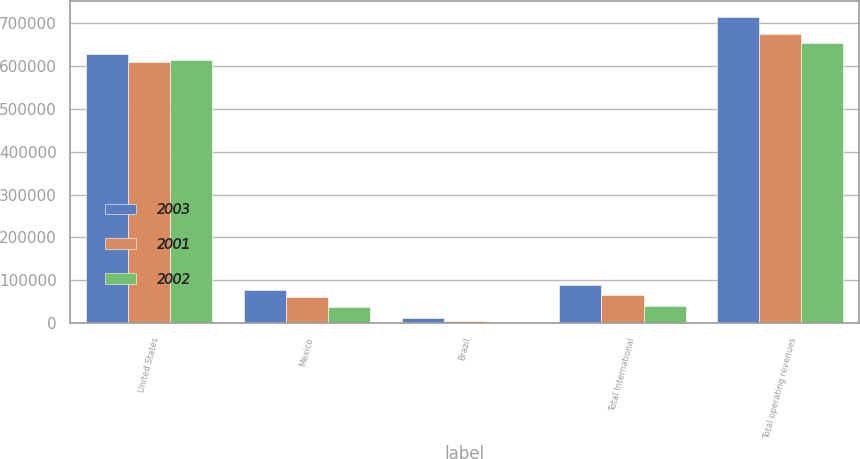Convert chart. <chart><loc_0><loc_0><loc_500><loc_500><stacked_bar_chart><ecel><fcel>United States<fcel>Mexico<fcel>Brazil<fcel>Total International<fcel>Total operating revenues<nl><fcel>2003<fcel>627049<fcel>76325<fcel>11770<fcel>88095<fcel>715144<nl><fcel>2001<fcel>610085<fcel>59996<fcel>5001<fcel>64997<fcel>675082<nl><fcel>2002<fcel>614313<fcel>37770<fcel>2894<fcel>40664<fcel>654977<nl></chart> 